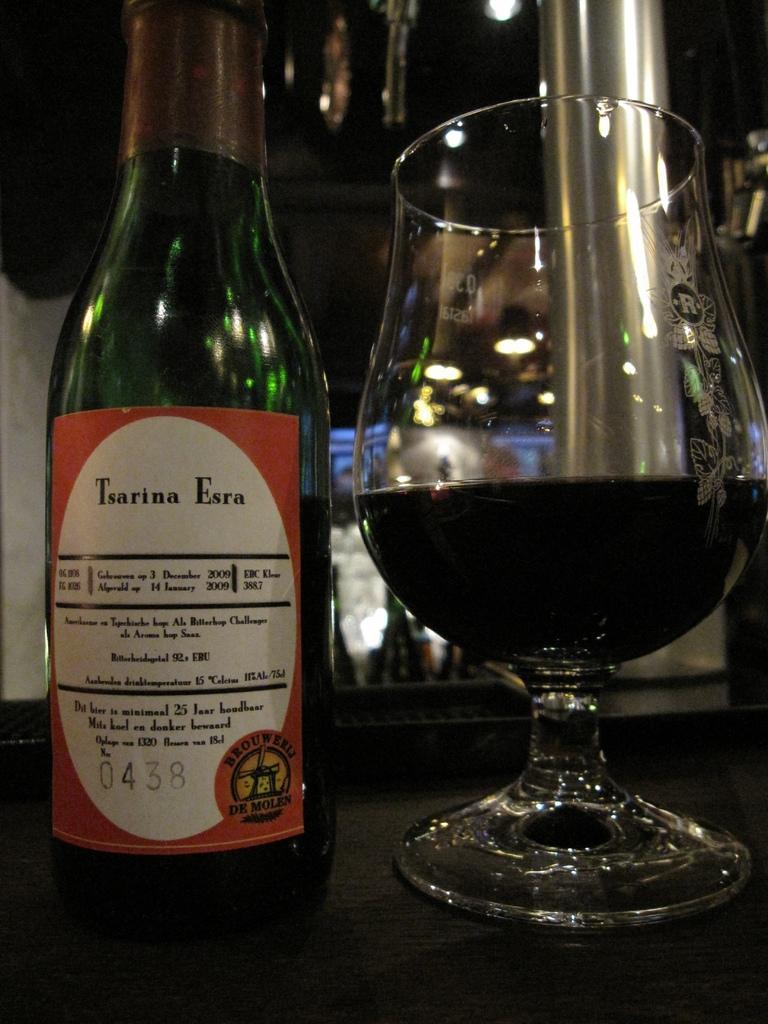How would you summarize this image in a sentence or two? This is a wooden table where a wine bottle and glass of wine are kept on it. 